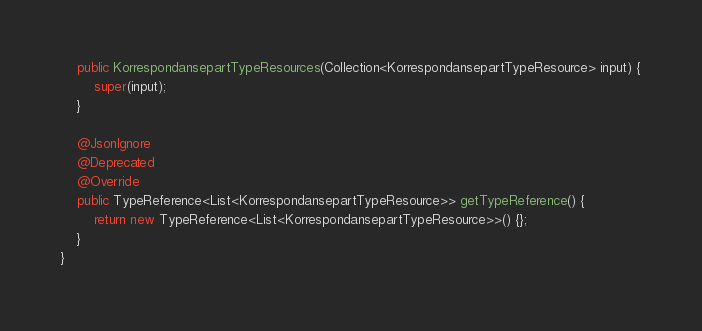Convert code to text. <code><loc_0><loc_0><loc_500><loc_500><_Java_>    public KorrespondansepartTypeResources(Collection<KorrespondansepartTypeResource> input) {
        super(input);
    }

    @JsonIgnore
    @Deprecated
    @Override
    public TypeReference<List<KorrespondansepartTypeResource>> getTypeReference() {
        return new TypeReference<List<KorrespondansepartTypeResource>>() {};
    }
}
</code> 